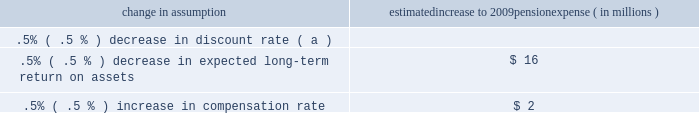The following were issued in 2007 : 2022 sfas 141 ( r ) , 201cbusiness combinations 201d 2022 sfas 160 , 201caccounting and reporting of noncontrolling interests in consolidated financial statements , an amendment of arb no .
51 201d 2022 sec staff accounting bulletin no .
109 2022 fin 46 ( r ) 7 , 201capplication of fasb interpretation no .
46 ( r ) to investment companies 201d 2022 fsp fin 48-1 , 201cdefinition of settlement in fasb interpretation ( 201cfin 201d ) no .
48 201d 2022 sfas 159 the following were issued in 2006 with an effective date in 2022 sfas 157 2022 the emerging issues task force ( 201ceitf 201d ) of the fasb issued eitf issue 06-4 , 201caccounting for deferred compensation and postretirement benefit aspects of endorsement split-dollar life insurance arrangements 201d status of defined benefit pension plan we have a noncontributory , qualified defined benefit pension plan ( 201cplan 201d or 201cpension plan 201d ) covering eligible employees .
Benefits are derived from a cash balance formula based on compensation levels , age and length of service .
Pension contributions are based on an actuarially determined amount necessary to fund total benefits payable to plan participants .
Consistent with our investment strategy , plan assets are primarily invested in equity investments and fixed income instruments .
Plan fiduciaries determine and review the plan 2019s investment policy .
We calculate the expense associated with the pension plan in accordance with sfas 87 , 201cemployers 2019 accounting for pensions , 201d and we use assumptions and methods that are compatible with the requirements of sfas 87 , including a policy of reflecting trust assets at their fair market value .
On an annual basis , we review the actuarial assumptions related to the pension plan , including the discount rate , the rate of compensation increase and the expected return on plan assets .
The discount rate and compensation increase assumptions do not significantly affect pension expense .
However , the expected long-term return on assets assumption does significantly affect pension expense .
The expected long-term return on plan assets for determining net periodic pension cost for 2008 was 8.25% ( 8.25 % ) , unchanged from 2007 .
Under current accounting rules , the difference between expected long-term returns and actual returns is accumulated and amortized to pension expense over future periods .
Each one percentage point difference in actual return compared with our expected return causes expense in subsequent years to change by up to $ 7 million as the impact is amortized into results of operations .
The table below reflects the estimated effects on pension expense of certain changes in annual assumptions , using 2009 estimated expense as a baseline .
Change in assumption estimated increase to 2009 pension expense ( in millions ) .
( a ) de minimis .
We currently estimate a pretax pension expense of $ 124 million in 2009 compared with a pretax benefit of $ 32 million in 2008 .
The 2009 values and sensitivities shown above include the qualified defined benefit plan maintained by national city that we merged into the pnc plan as of december 31 , 2008 .
The expected increase in pension cost is attributable not only to the national city acquisition , but also to the significant variance between 2008 actual investment returns and long-term expected returns .
Our pension plan contribution requirements are not particularly sensitive to actuarial assumptions .
Investment performance has the most impact on contribution requirements and will drive the amount of permitted contributions in future years .
Also , current law , including the provisions of the pension protection act of 2006 , sets limits as to both minimum and maximum contributions to the plan .
We expect that the minimum required contributions under the law will be zero for 2009 .
We maintain other defined benefit plans that have a less significant effect on financial results , including various nonqualified supplemental retirement plans for certain employees .
See note 15 employee benefit plans in the notes to consolidated financial statements in item 8 of this report for additional information .
Risk management we encounter risk as part of the normal course of our business and we design risk management processes to help manage these risks .
This risk management section first provides an overview of the risk measurement , control strategies , and monitoring aspects of our corporate-level risk management processes .
Following that discussion is an analysis of the risk management process for what we view as our primary areas of risk : credit , operational , liquidity , and market .
The discussion of market risk is further subdivided into interest rate , trading , and equity and other investment risk areas .
Our use of financial derivatives as part of our overall asset and liability risk management process is also addressed within the risk management section of this item 7 .
In appropriate places within this section , historical performance is also addressed. .
Is pretax pension expense in 2009 larger when compared with a pretax benefit in 2008? 
Computations: (124 > 32)
Answer: yes. 